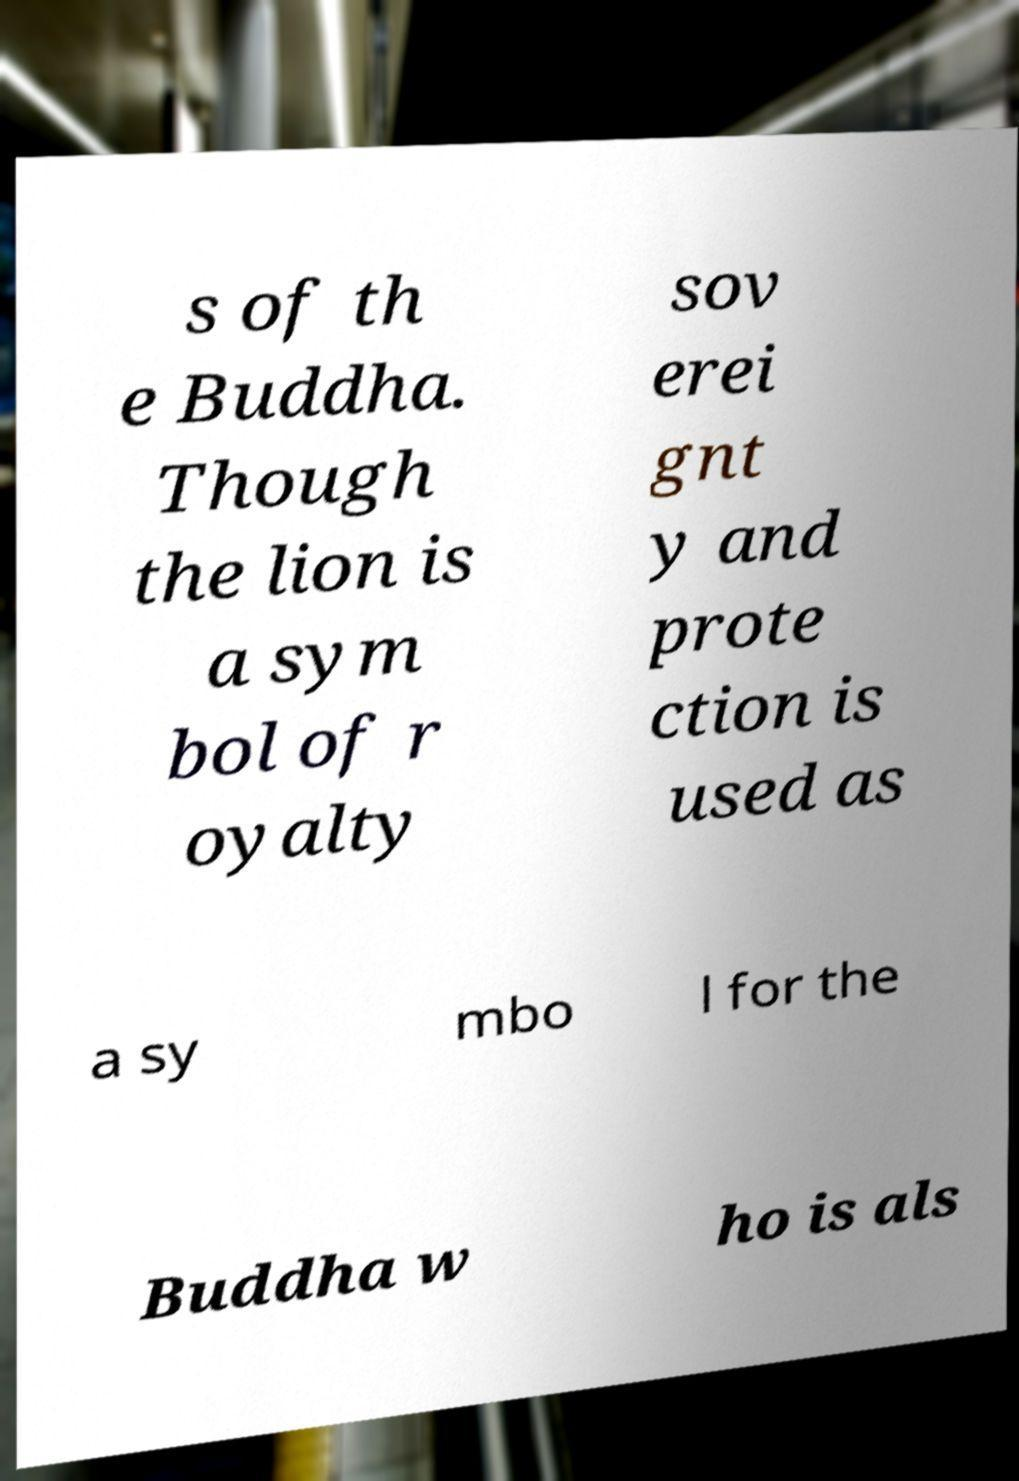Can you read and provide the text displayed in the image?This photo seems to have some interesting text. Can you extract and type it out for me? s of th e Buddha. Though the lion is a sym bol of r oyalty sov erei gnt y and prote ction is used as a sy mbo l for the Buddha w ho is als 